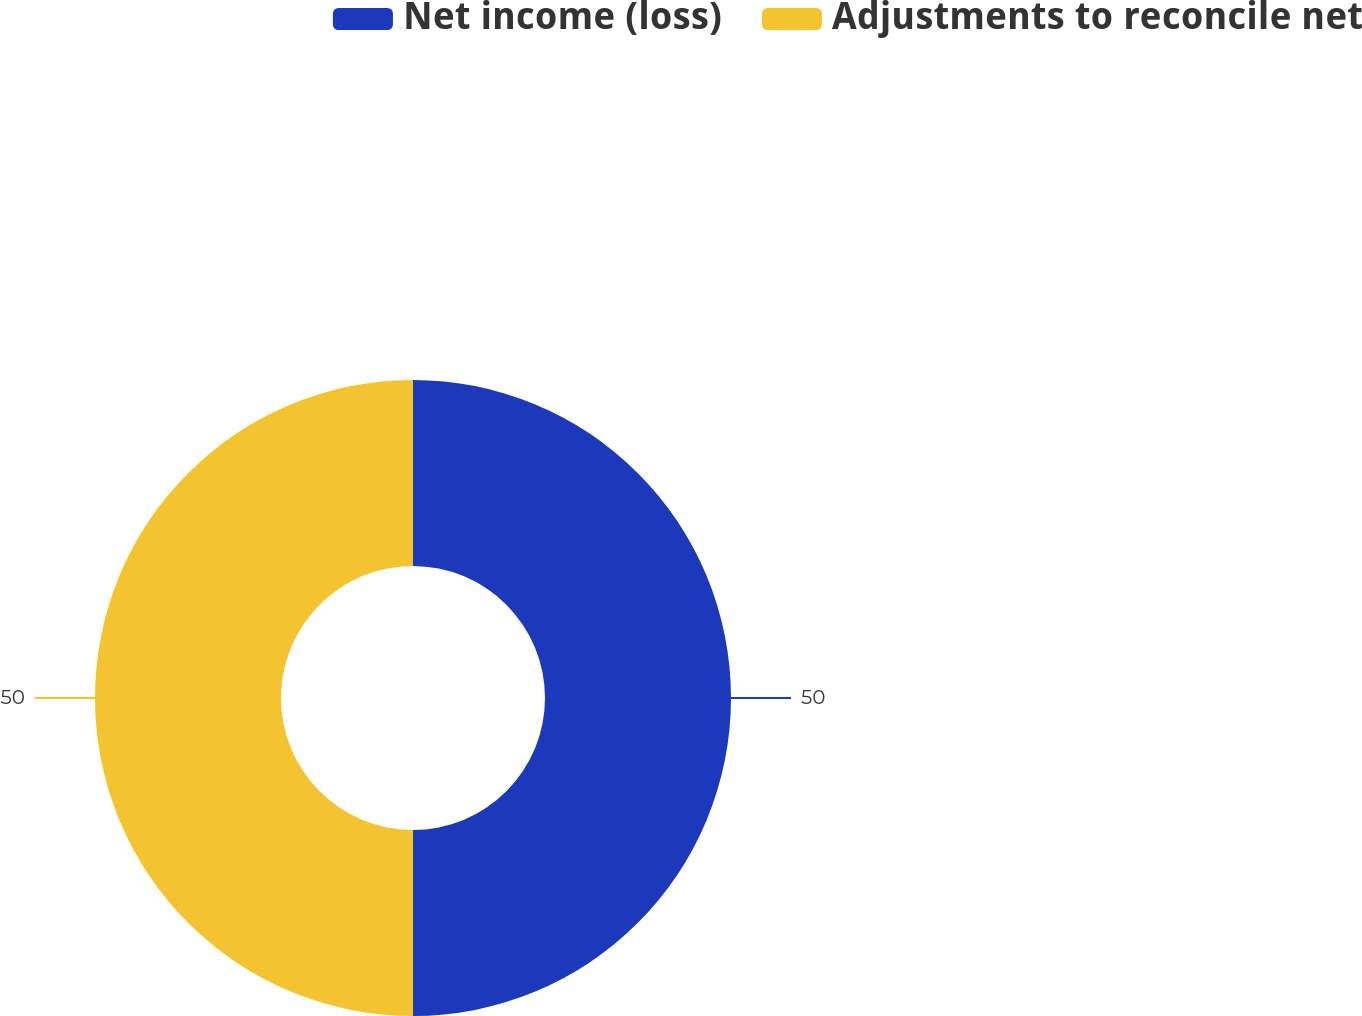Convert chart. <chart><loc_0><loc_0><loc_500><loc_500><pie_chart><fcel>Net income (loss)<fcel>Adjustments to reconcile net<nl><fcel>50.0%<fcel>50.0%<nl></chart> 